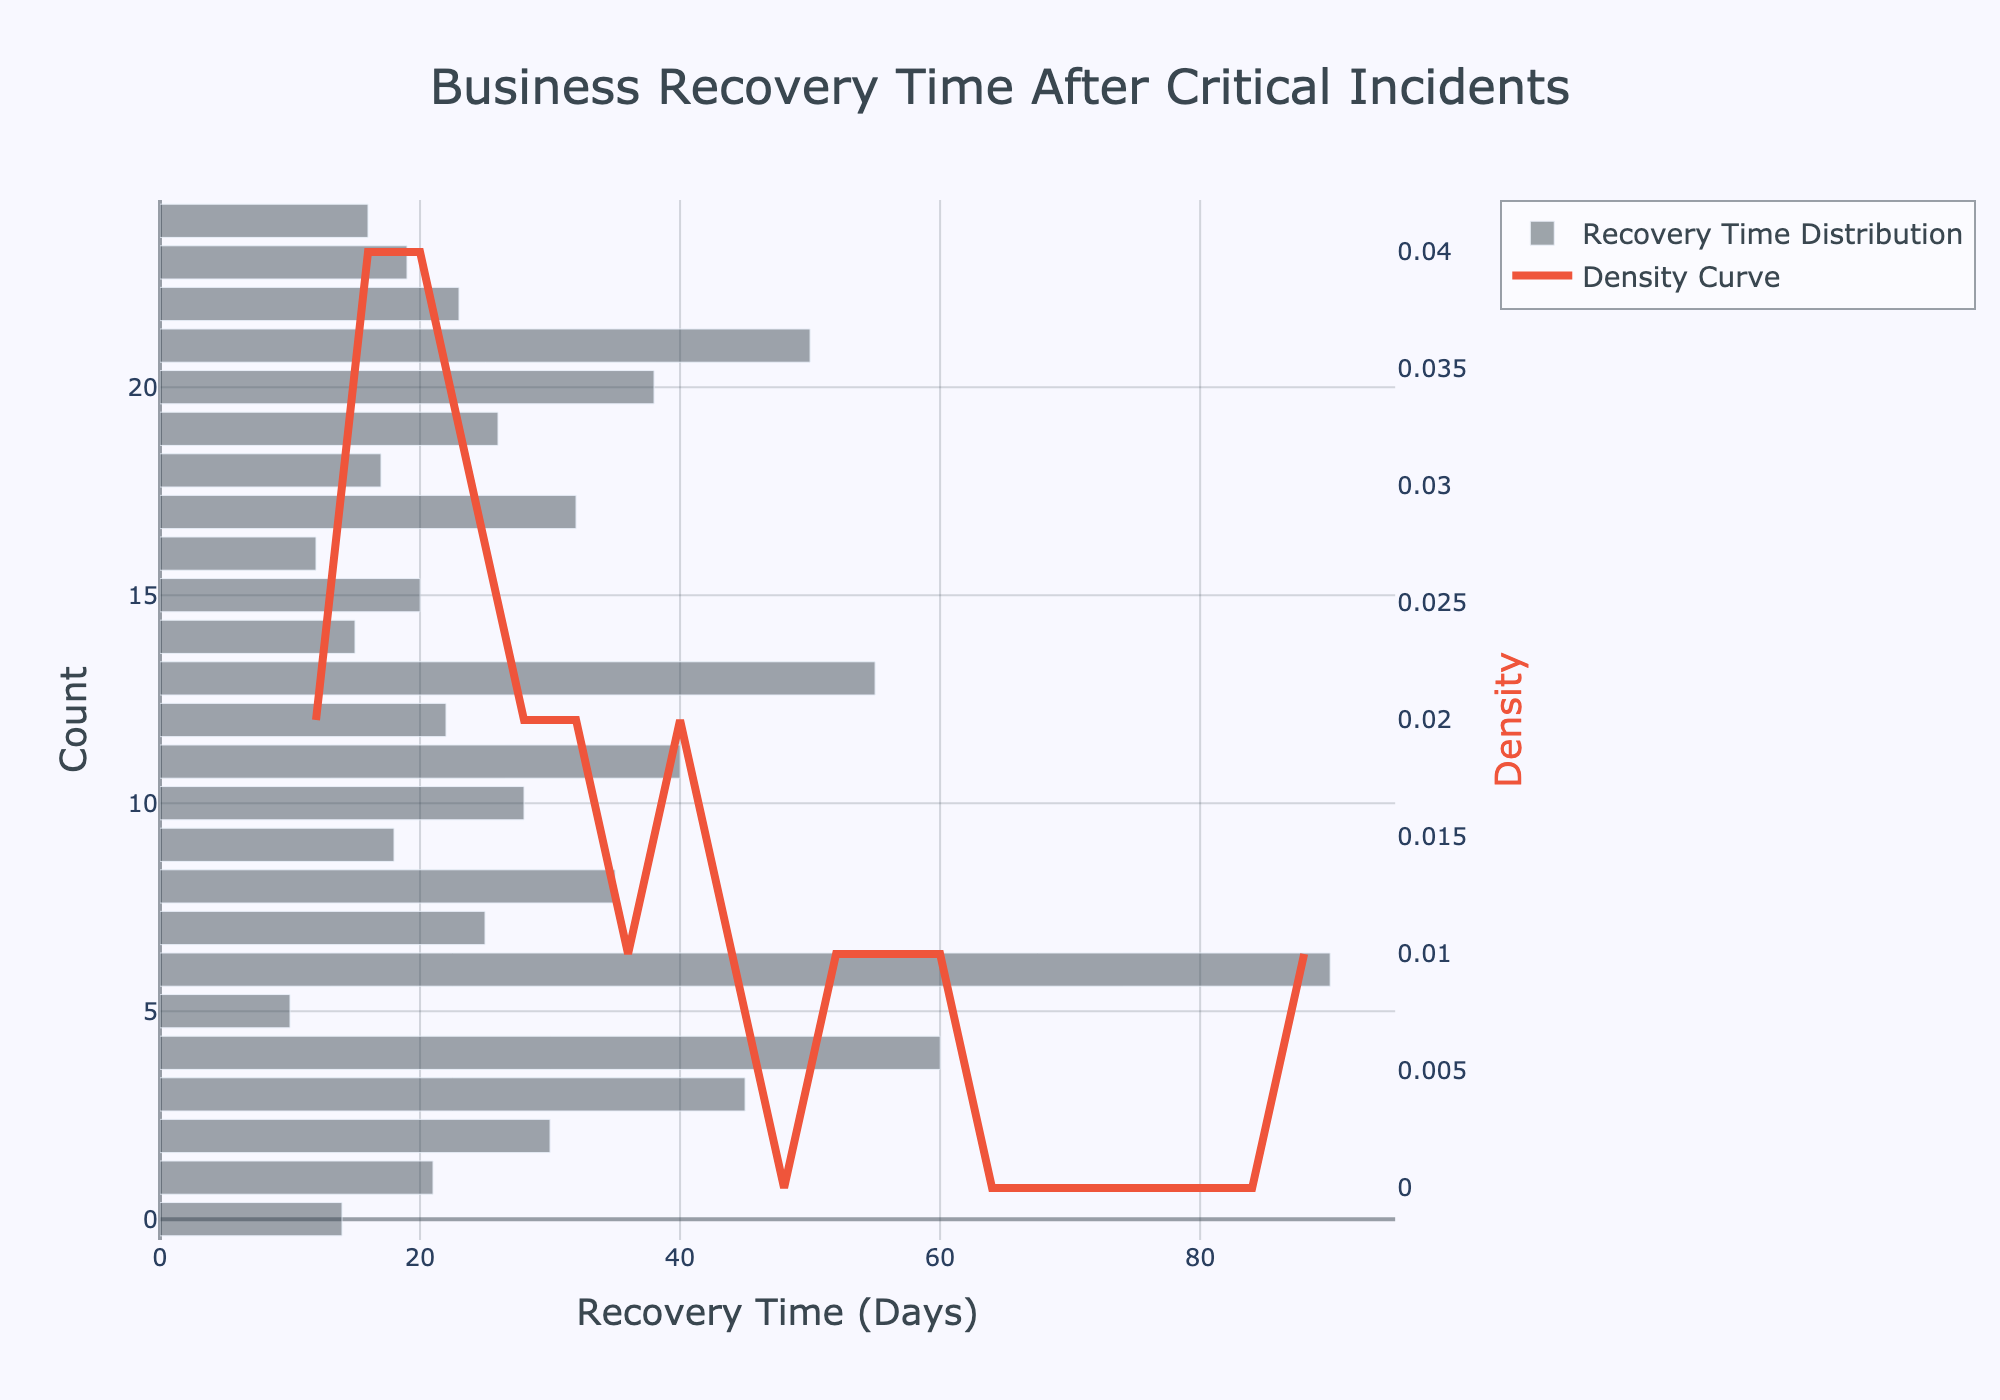How many different companies' recovery times are included in the histogram? By counting the number of different companies listed in the dataset, you can determine the number of entries in the histogram.
Answer: 25 What is the range of the recovery times shown in the histogram? The recovery time ranges from the minimum to the maximum values in the dataset. In this case, the minimum recovery time is 10 days (Apple), and the maximum is 90 days (Boeing).
Answer: 10 to 90 days Which recovery time category (range) has the highest bar in the histogram? The highest bar can be identified by observing the tallest column in the histogram, which represents the category with the most frequent occurrences of recovery times.
Answer: 20 to 30 days How is the recovery time distribution of businesses visualized with colors? The histogram bars are depicted in a translucent gray color, while the KDE (density curve) is presented in a vivid red color.
Answer: Gray bars and a red curve What does the KDE (density curve) represent in this plot? The KDE (density curve) visually represents the probability density function, indicating where recovery times are more concentrated or frequent across the dataset.
Answer: Density/probability distribution Is the distribution of recovery times skewed? If so, in which direction? By examining the KDE curve, you can see if the curve tails off more on one side. In this case, the curve tails off more towards the right, indicating a positive skew.
Answer: Positively skewed Which company experienced the shortest recovery time? By examining the data or the shorter bars in the histogram, you find that Apple has the shortest recovery time of 10 days.
Answer: Apple How does the recovery time for Boeing compare to the mean recovery time? To find Boeing's recovery time (90 days) and compare it to the mean recovery time, check the KDE curve or calculate the average. The mean appears lower than Boeing's recovery time.
Answer: Higher than the mean What can you infer about the recovery times of companies that fall within the 20 to 30 days range? Observing the histogram bar height and KDE curve within this range indicates that many companies' recovery times fall in this range, suggesting it is a common recovery period.
Answer: Common recovery period Which data point likely contributes most to the positive skew observed in the histogram? The high recovery times (e.g., Boeing at 90 days) cause the positive skew, as they pull the tail of the distribution to the right.
Answer: Boeing's recovery time 